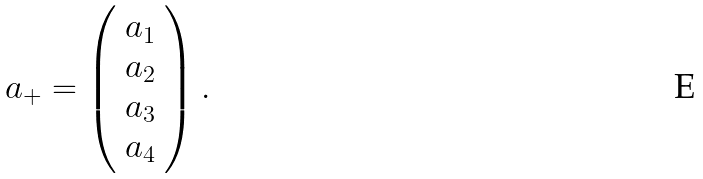<formula> <loc_0><loc_0><loc_500><loc_500>a _ { + } = \left ( \begin{array} { c } a _ { 1 } \\ a _ { 2 } \\ a _ { 3 } \\ a _ { 4 } \end{array} \right ) .</formula> 